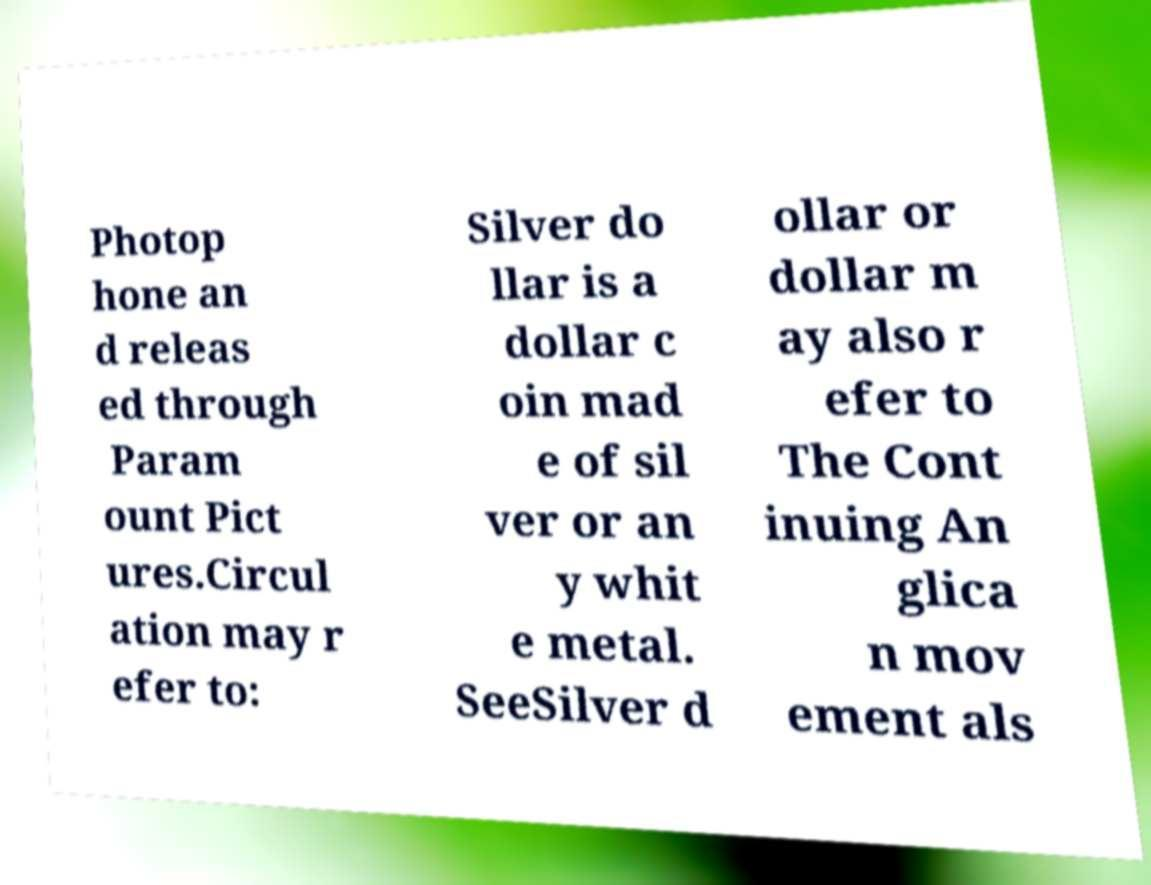There's text embedded in this image that I need extracted. Can you transcribe it verbatim? Photop hone an d releas ed through Param ount Pict ures.Circul ation may r efer to: Silver do llar is a dollar c oin mad e of sil ver or an y whit e metal. SeeSilver d ollar or dollar m ay also r efer to The Cont inuing An glica n mov ement als 